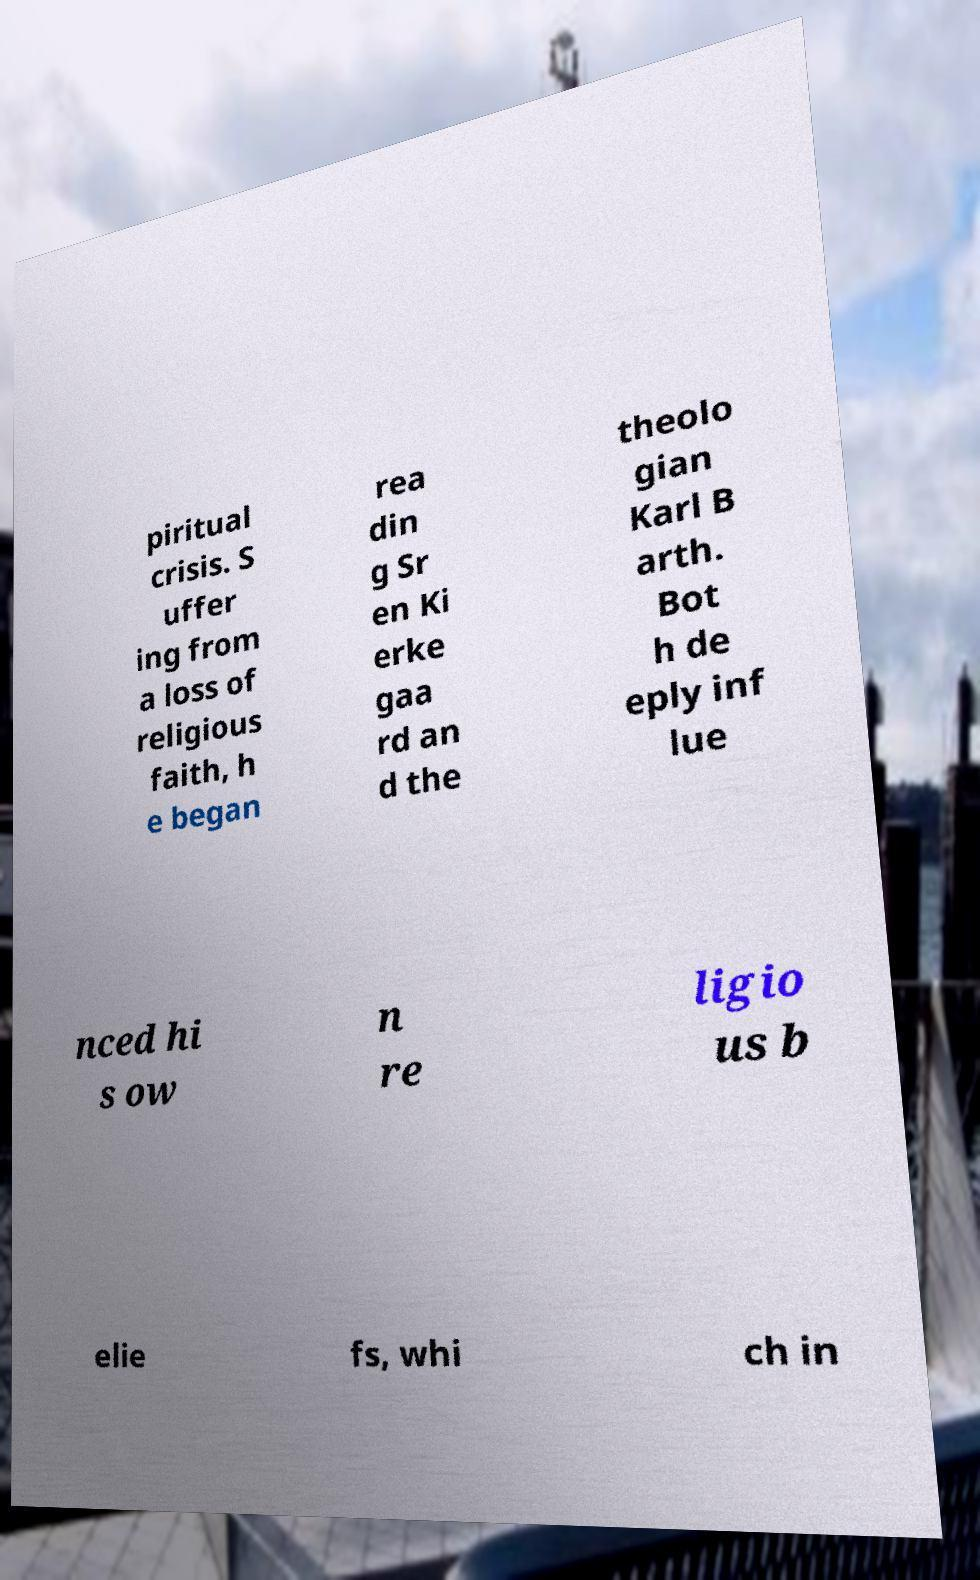I need the written content from this picture converted into text. Can you do that? piritual crisis. S uffer ing from a loss of religious faith, h e began rea din g Sr en Ki erke gaa rd an d the theolo gian Karl B arth. Bot h de eply inf lue nced hi s ow n re ligio us b elie fs, whi ch in 